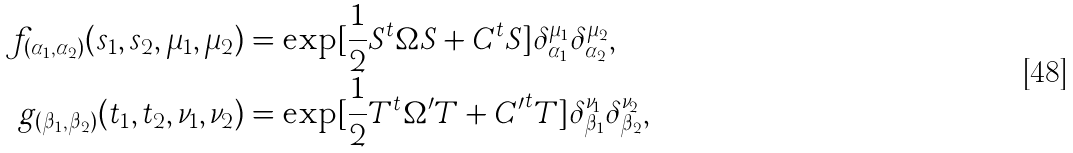<formula> <loc_0><loc_0><loc_500><loc_500>f _ { ( \alpha _ { 1 } , \alpha _ { 2 } ) } ( s _ { 1 } , s _ { 2 } , \mu _ { 1 } , \mu _ { 2 } ) & = \exp [ \frac { 1 } { 2 } S ^ { t } \Omega S + C ^ { t } S ] \delta _ { \alpha _ { 1 } } ^ { \mu _ { 1 } } \delta _ { \alpha _ { 2 } } ^ { \mu _ { 2 } } , \\ g _ { ( \beta _ { 1 } , \beta _ { 2 } ) } ( t _ { 1 } , t _ { 2 } , \nu _ { 1 } , \nu _ { 2 } ) & = \exp [ \frac { 1 } { 2 } T ^ { t } \Omega ^ { \prime } T + { C ^ { \prime } } ^ { t } T ] \delta _ { \beta _ { 1 } } ^ { \nu _ { 1 } } \delta _ { \beta _ { 2 } } ^ { \nu _ { 2 } } ,</formula> 